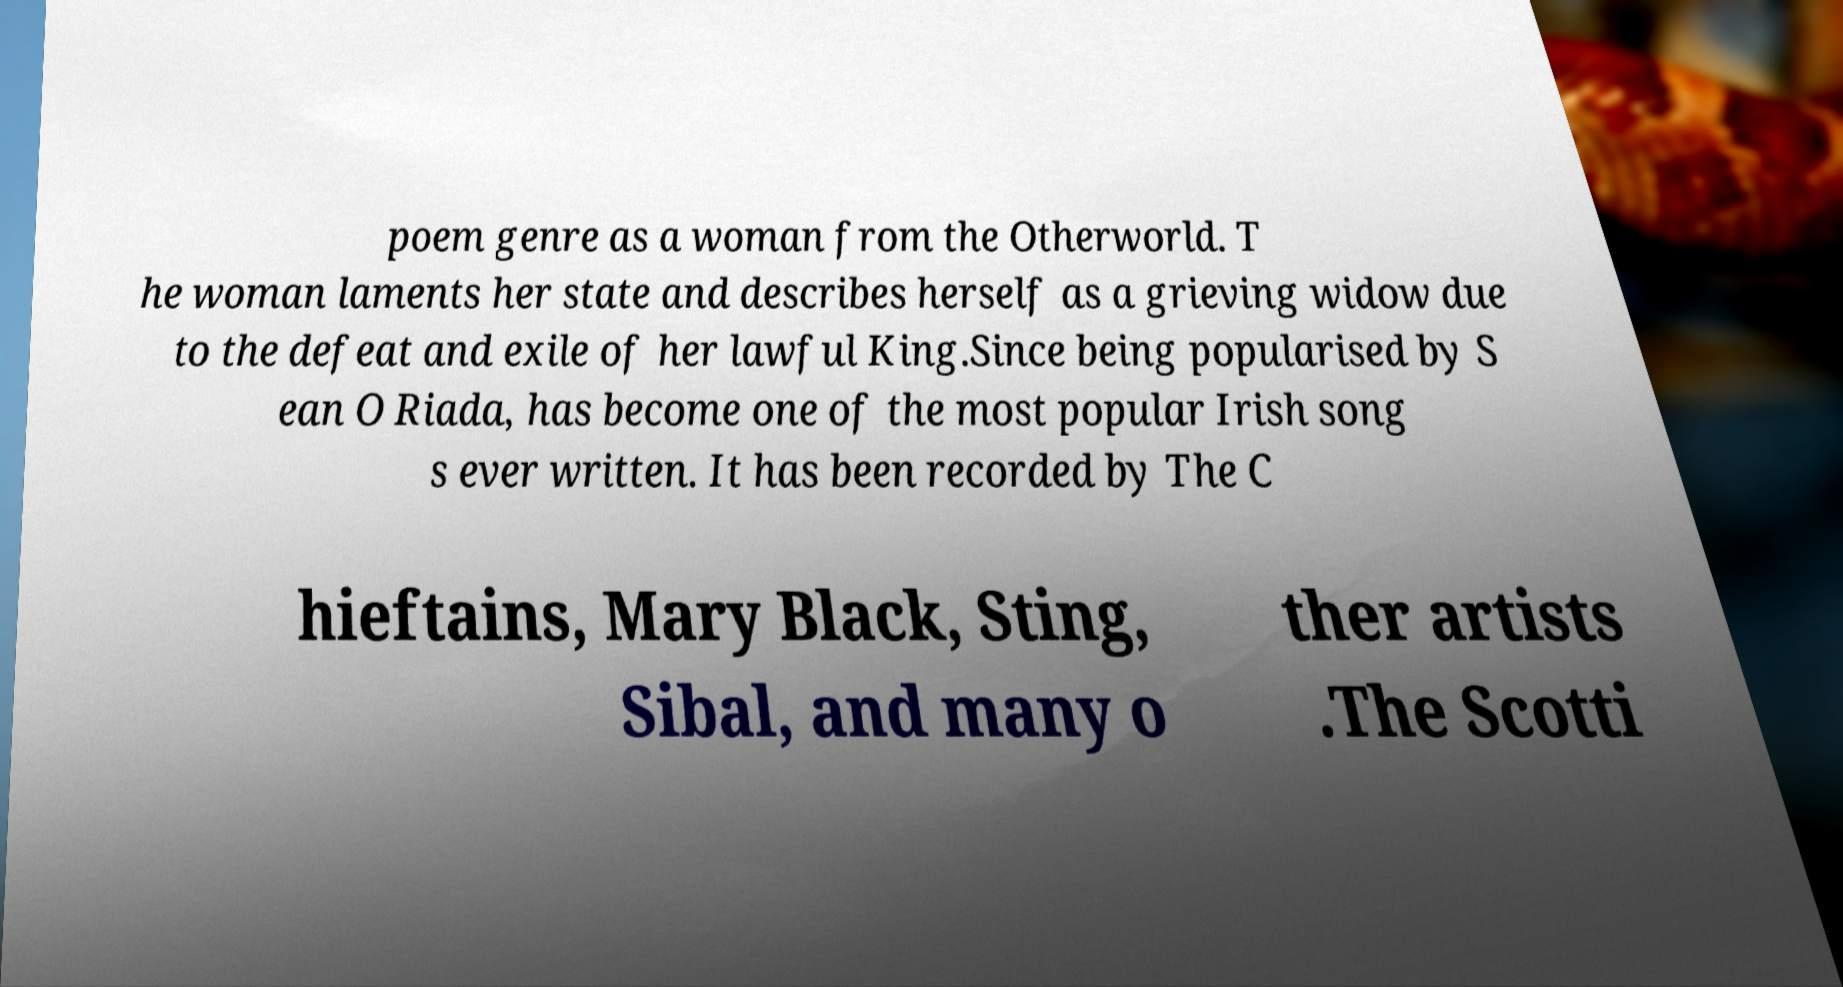Can you read and provide the text displayed in the image?This photo seems to have some interesting text. Can you extract and type it out for me? poem genre as a woman from the Otherworld. T he woman laments her state and describes herself as a grieving widow due to the defeat and exile of her lawful King.Since being popularised by S ean O Riada, has become one of the most popular Irish song s ever written. It has been recorded by The C hieftains, Mary Black, Sting, Sibal, and many o ther artists .The Scotti 